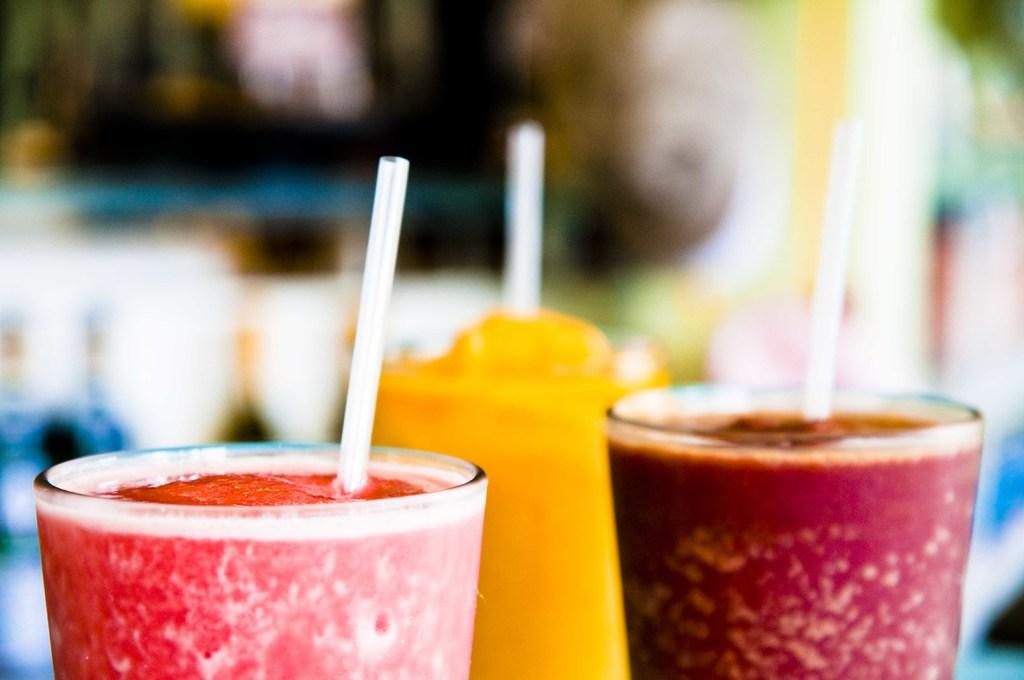How many glasses are visible in the image? There are three glasses in the image. What is in each glass? Each glass has a straw in it, and they contain juice. Can you describe the background of the image? The background of the image is blurred. What type of paint is being used to create the joke in the image? There is no paint or joke present in the image; it features three glasses with straws and juice. 